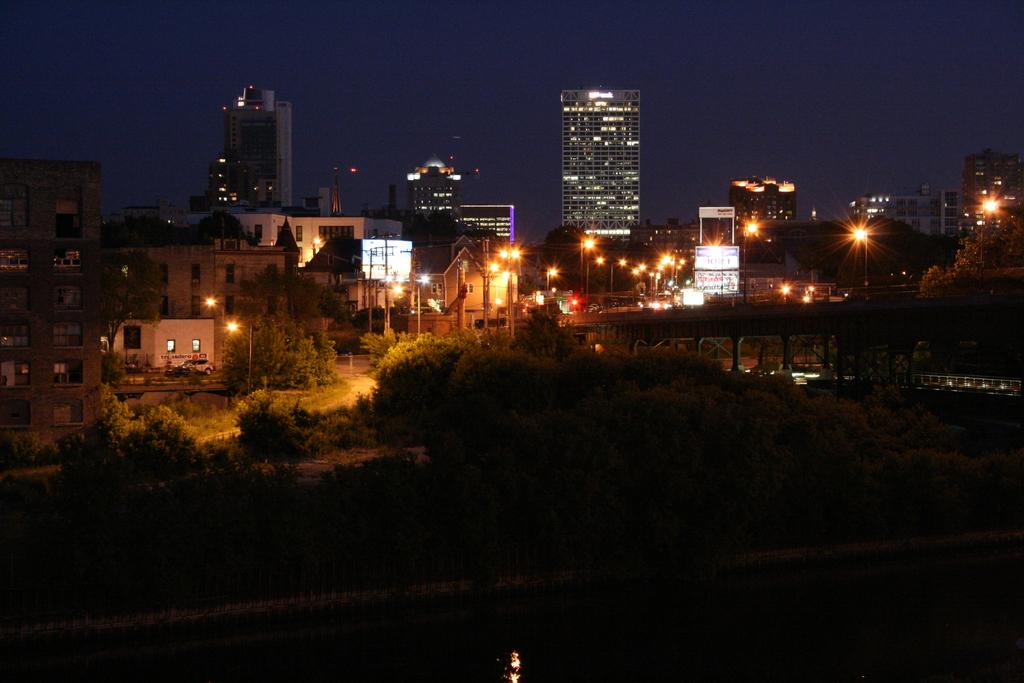What type of structures can be seen in the image? There are buildings in the image. What else is visible in the image besides the buildings? There are lights, grass, trees, and the sky visible in the image. Can you describe the vegetation present in the image? There is grass and trees in the image. What is visible at the top of the image? The sky is visible at the top of the image. How many cherries can be seen hanging from the trees in the image? There are no cherries present in the image; it features buildings, lights, grass, trees, and the sky. What type of horn is visible on the buildings in the image? There is no horn visible on the buildings in the image. 